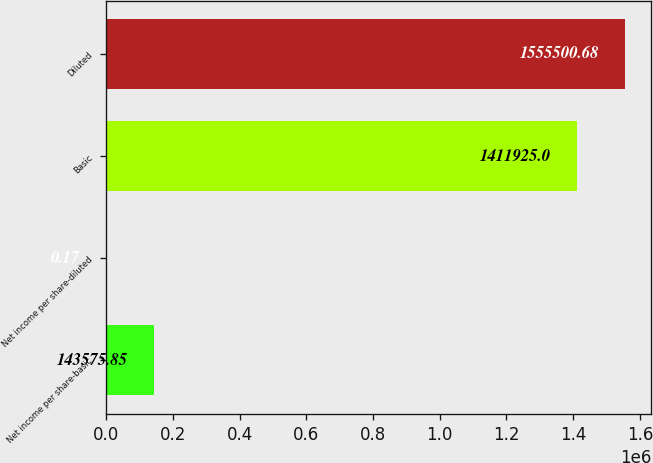<chart> <loc_0><loc_0><loc_500><loc_500><bar_chart><fcel>Net income per share-basic<fcel>Net income per share-diluted<fcel>Basic<fcel>Diluted<nl><fcel>143576<fcel>0.17<fcel>1.41192e+06<fcel>1.5555e+06<nl></chart> 